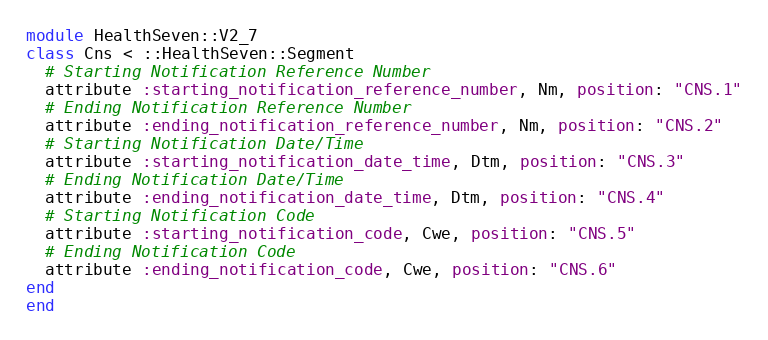<code> <loc_0><loc_0><loc_500><loc_500><_Ruby_>module HealthSeven::V2_7
class Cns < ::HealthSeven::Segment
  # Starting Notification Reference Number
  attribute :starting_notification_reference_number, Nm, position: "CNS.1"
  # Ending Notification Reference Number
  attribute :ending_notification_reference_number, Nm, position: "CNS.2"
  # Starting Notification Date/Time
  attribute :starting_notification_date_time, Dtm, position: "CNS.3"
  # Ending Notification Date/Time
  attribute :ending_notification_date_time, Dtm, position: "CNS.4"
  # Starting Notification Code
  attribute :starting_notification_code, Cwe, position: "CNS.5"
  # Ending Notification Code
  attribute :ending_notification_code, Cwe, position: "CNS.6"
end
end</code> 